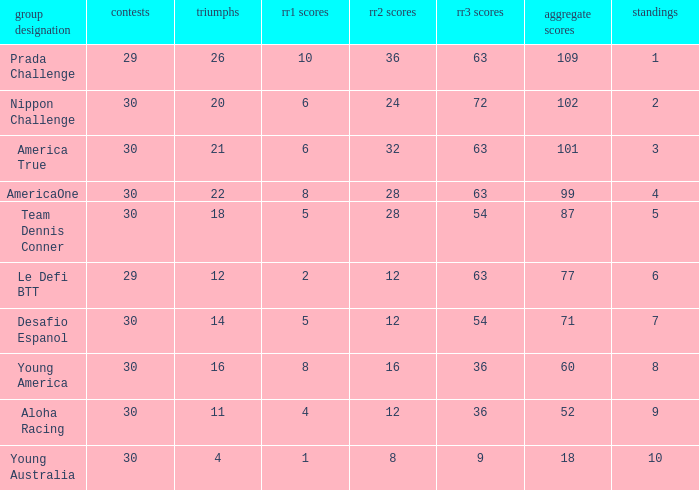Name the races for the prada challenge 29.0. 